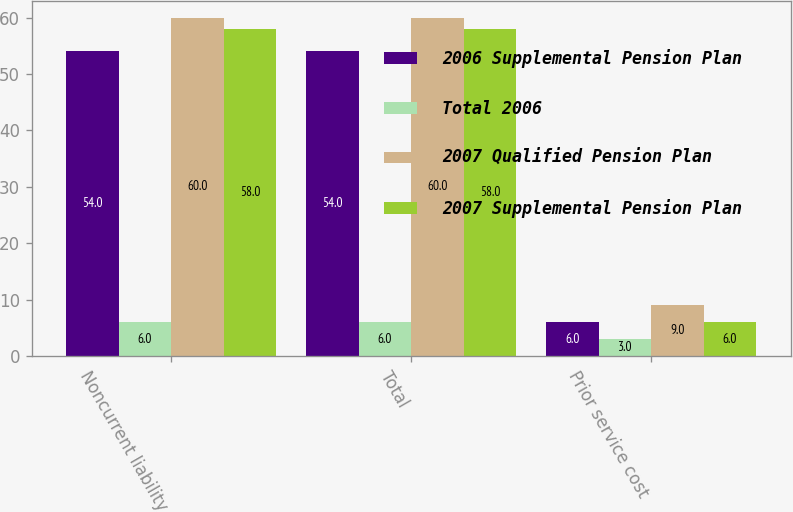Convert chart to OTSL. <chart><loc_0><loc_0><loc_500><loc_500><stacked_bar_chart><ecel><fcel>Noncurrent liability<fcel>Total<fcel>Prior service cost<nl><fcel>2006 Supplemental Pension Plan<fcel>54<fcel>54<fcel>6<nl><fcel>Total 2006<fcel>6<fcel>6<fcel>3<nl><fcel>2007 Qualified Pension Plan<fcel>60<fcel>60<fcel>9<nl><fcel>2007 Supplemental Pension Plan<fcel>58<fcel>58<fcel>6<nl></chart> 